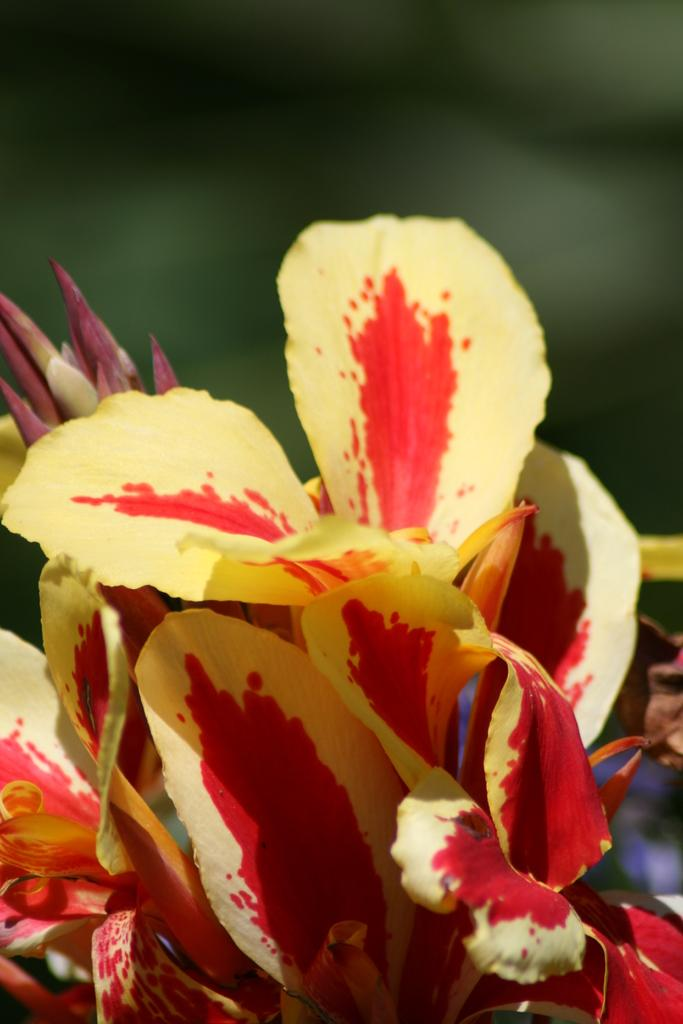What is present in the image? There are flowers in the image. Can you describe the background of the image? The background of the image is blurry. What type of lip can be seen on the flower in the image? There are no lips present in the image, as it features flowers and a blurry background. 